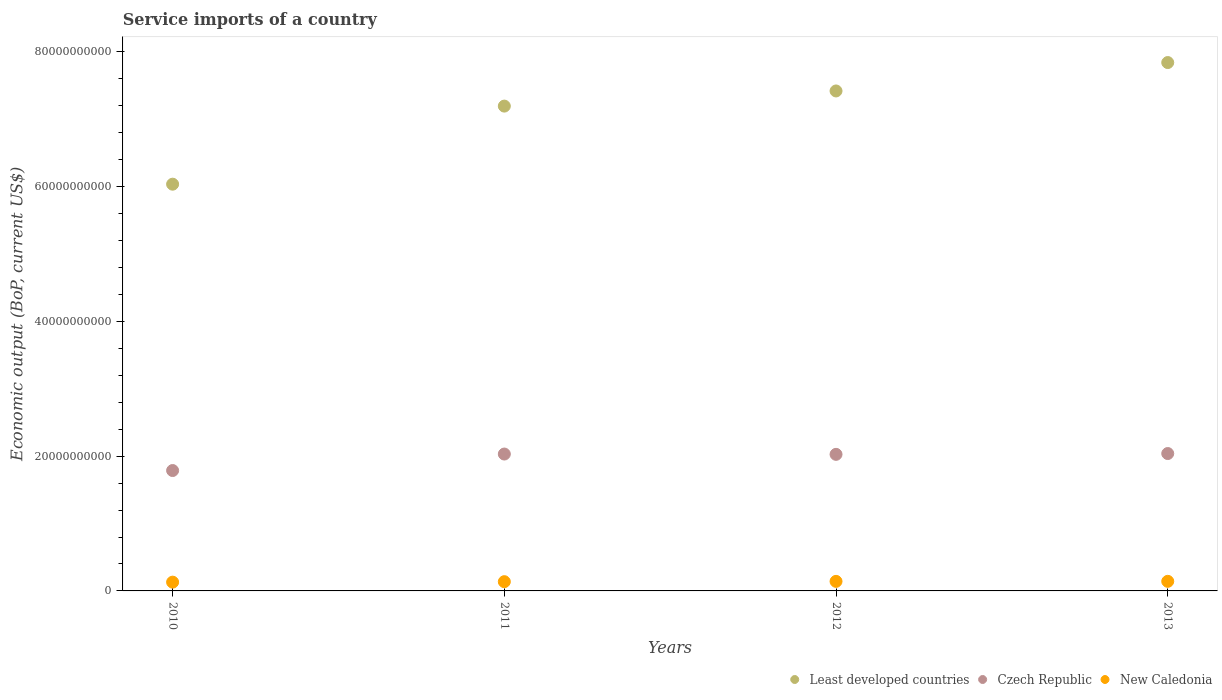Is the number of dotlines equal to the number of legend labels?
Offer a terse response. Yes. What is the service imports in Least developed countries in 2012?
Give a very brief answer. 7.42e+1. Across all years, what is the maximum service imports in Czech Republic?
Provide a short and direct response. 2.04e+1. Across all years, what is the minimum service imports in Least developed countries?
Your answer should be very brief. 6.04e+1. In which year was the service imports in New Caledonia maximum?
Make the answer very short. 2013. What is the total service imports in New Caledonia in the graph?
Provide a short and direct response. 5.51e+09. What is the difference between the service imports in Czech Republic in 2011 and that in 2012?
Make the answer very short. 4.52e+07. What is the difference between the service imports in Least developed countries in 2011 and the service imports in Czech Republic in 2012?
Your answer should be very brief. 5.17e+1. What is the average service imports in Least developed countries per year?
Give a very brief answer. 7.12e+1. In the year 2013, what is the difference between the service imports in New Caledonia and service imports in Least developed countries?
Give a very brief answer. -7.70e+1. In how many years, is the service imports in Least developed countries greater than 16000000000 US$?
Give a very brief answer. 4. What is the ratio of the service imports in Least developed countries in 2012 to that in 2013?
Your answer should be compact. 0.95. Is the difference between the service imports in New Caledonia in 2011 and 2012 greater than the difference between the service imports in Least developed countries in 2011 and 2012?
Make the answer very short. Yes. What is the difference between the highest and the second highest service imports in New Caledonia?
Offer a very short reply. 5.28e+06. What is the difference between the highest and the lowest service imports in Czech Republic?
Your answer should be compact. 2.52e+09. Does the service imports in Czech Republic monotonically increase over the years?
Give a very brief answer. No. Is the service imports in Least developed countries strictly greater than the service imports in New Caledonia over the years?
Keep it short and to the point. Yes. Is the service imports in Least developed countries strictly less than the service imports in Czech Republic over the years?
Give a very brief answer. No. How many dotlines are there?
Keep it short and to the point. 3. How many years are there in the graph?
Ensure brevity in your answer.  4. What is the difference between two consecutive major ticks on the Y-axis?
Make the answer very short. 2.00e+1. Does the graph contain grids?
Offer a very short reply. No. Where does the legend appear in the graph?
Make the answer very short. Bottom right. What is the title of the graph?
Make the answer very short. Service imports of a country. Does "Kuwait" appear as one of the legend labels in the graph?
Your answer should be compact. No. What is the label or title of the X-axis?
Provide a succinct answer. Years. What is the label or title of the Y-axis?
Provide a succinct answer. Economic output (BoP, current US$). What is the Economic output (BoP, current US$) in Least developed countries in 2010?
Provide a short and direct response. 6.04e+1. What is the Economic output (BoP, current US$) in Czech Republic in 2010?
Your answer should be very brief. 1.79e+1. What is the Economic output (BoP, current US$) in New Caledonia in 2010?
Make the answer very short. 1.30e+09. What is the Economic output (BoP, current US$) in Least developed countries in 2011?
Give a very brief answer. 7.19e+1. What is the Economic output (BoP, current US$) in Czech Republic in 2011?
Make the answer very short. 2.03e+1. What is the Economic output (BoP, current US$) of New Caledonia in 2011?
Your answer should be very brief. 1.37e+09. What is the Economic output (BoP, current US$) of Least developed countries in 2012?
Offer a very short reply. 7.42e+1. What is the Economic output (BoP, current US$) of Czech Republic in 2012?
Offer a very short reply. 2.03e+1. What is the Economic output (BoP, current US$) of New Caledonia in 2012?
Ensure brevity in your answer.  1.42e+09. What is the Economic output (BoP, current US$) in Least developed countries in 2013?
Offer a terse response. 7.84e+1. What is the Economic output (BoP, current US$) of Czech Republic in 2013?
Offer a very short reply. 2.04e+1. What is the Economic output (BoP, current US$) in New Caledonia in 2013?
Give a very brief answer. 1.42e+09. Across all years, what is the maximum Economic output (BoP, current US$) in Least developed countries?
Your answer should be compact. 7.84e+1. Across all years, what is the maximum Economic output (BoP, current US$) of Czech Republic?
Your answer should be very brief. 2.04e+1. Across all years, what is the maximum Economic output (BoP, current US$) of New Caledonia?
Make the answer very short. 1.42e+09. Across all years, what is the minimum Economic output (BoP, current US$) of Least developed countries?
Your response must be concise. 6.04e+1. Across all years, what is the minimum Economic output (BoP, current US$) in Czech Republic?
Ensure brevity in your answer.  1.79e+1. Across all years, what is the minimum Economic output (BoP, current US$) of New Caledonia?
Offer a very short reply. 1.30e+09. What is the total Economic output (BoP, current US$) of Least developed countries in the graph?
Provide a short and direct response. 2.85e+11. What is the total Economic output (BoP, current US$) of Czech Republic in the graph?
Keep it short and to the point. 7.88e+1. What is the total Economic output (BoP, current US$) in New Caledonia in the graph?
Provide a succinct answer. 5.51e+09. What is the difference between the Economic output (BoP, current US$) of Least developed countries in 2010 and that in 2011?
Keep it short and to the point. -1.16e+1. What is the difference between the Economic output (BoP, current US$) in Czech Republic in 2010 and that in 2011?
Offer a very short reply. -2.45e+09. What is the difference between the Economic output (BoP, current US$) of New Caledonia in 2010 and that in 2011?
Provide a short and direct response. -7.04e+07. What is the difference between the Economic output (BoP, current US$) in Least developed countries in 2010 and that in 2012?
Ensure brevity in your answer.  -1.38e+1. What is the difference between the Economic output (BoP, current US$) of Czech Republic in 2010 and that in 2012?
Provide a short and direct response. -2.40e+09. What is the difference between the Economic output (BoP, current US$) of New Caledonia in 2010 and that in 2012?
Your answer should be compact. -1.16e+08. What is the difference between the Economic output (BoP, current US$) in Least developed countries in 2010 and that in 2013?
Ensure brevity in your answer.  -1.80e+1. What is the difference between the Economic output (BoP, current US$) of Czech Republic in 2010 and that in 2013?
Offer a very short reply. -2.52e+09. What is the difference between the Economic output (BoP, current US$) in New Caledonia in 2010 and that in 2013?
Offer a very short reply. -1.21e+08. What is the difference between the Economic output (BoP, current US$) in Least developed countries in 2011 and that in 2012?
Provide a succinct answer. -2.25e+09. What is the difference between the Economic output (BoP, current US$) of Czech Republic in 2011 and that in 2012?
Offer a very short reply. 4.52e+07. What is the difference between the Economic output (BoP, current US$) of New Caledonia in 2011 and that in 2012?
Offer a terse response. -4.57e+07. What is the difference between the Economic output (BoP, current US$) in Least developed countries in 2011 and that in 2013?
Provide a short and direct response. -6.46e+09. What is the difference between the Economic output (BoP, current US$) in Czech Republic in 2011 and that in 2013?
Keep it short and to the point. -7.53e+07. What is the difference between the Economic output (BoP, current US$) in New Caledonia in 2011 and that in 2013?
Your answer should be compact. -5.10e+07. What is the difference between the Economic output (BoP, current US$) of Least developed countries in 2012 and that in 2013?
Your answer should be very brief. -4.21e+09. What is the difference between the Economic output (BoP, current US$) of Czech Republic in 2012 and that in 2013?
Provide a succinct answer. -1.21e+08. What is the difference between the Economic output (BoP, current US$) of New Caledonia in 2012 and that in 2013?
Provide a short and direct response. -5.28e+06. What is the difference between the Economic output (BoP, current US$) of Least developed countries in 2010 and the Economic output (BoP, current US$) of Czech Republic in 2011?
Give a very brief answer. 4.00e+1. What is the difference between the Economic output (BoP, current US$) in Least developed countries in 2010 and the Economic output (BoP, current US$) in New Caledonia in 2011?
Give a very brief answer. 5.90e+1. What is the difference between the Economic output (BoP, current US$) in Czech Republic in 2010 and the Economic output (BoP, current US$) in New Caledonia in 2011?
Provide a succinct answer. 1.65e+1. What is the difference between the Economic output (BoP, current US$) in Least developed countries in 2010 and the Economic output (BoP, current US$) in Czech Republic in 2012?
Ensure brevity in your answer.  4.01e+1. What is the difference between the Economic output (BoP, current US$) in Least developed countries in 2010 and the Economic output (BoP, current US$) in New Caledonia in 2012?
Your answer should be compact. 5.89e+1. What is the difference between the Economic output (BoP, current US$) of Czech Republic in 2010 and the Economic output (BoP, current US$) of New Caledonia in 2012?
Keep it short and to the point. 1.64e+1. What is the difference between the Economic output (BoP, current US$) of Least developed countries in 2010 and the Economic output (BoP, current US$) of Czech Republic in 2013?
Your answer should be very brief. 4.00e+1. What is the difference between the Economic output (BoP, current US$) of Least developed countries in 2010 and the Economic output (BoP, current US$) of New Caledonia in 2013?
Ensure brevity in your answer.  5.89e+1. What is the difference between the Economic output (BoP, current US$) of Czech Republic in 2010 and the Economic output (BoP, current US$) of New Caledonia in 2013?
Provide a short and direct response. 1.64e+1. What is the difference between the Economic output (BoP, current US$) of Least developed countries in 2011 and the Economic output (BoP, current US$) of Czech Republic in 2012?
Your response must be concise. 5.17e+1. What is the difference between the Economic output (BoP, current US$) of Least developed countries in 2011 and the Economic output (BoP, current US$) of New Caledonia in 2012?
Your answer should be compact. 7.05e+1. What is the difference between the Economic output (BoP, current US$) in Czech Republic in 2011 and the Economic output (BoP, current US$) in New Caledonia in 2012?
Your response must be concise. 1.89e+1. What is the difference between the Economic output (BoP, current US$) of Least developed countries in 2011 and the Economic output (BoP, current US$) of Czech Republic in 2013?
Offer a very short reply. 5.16e+1. What is the difference between the Economic output (BoP, current US$) in Least developed countries in 2011 and the Economic output (BoP, current US$) in New Caledonia in 2013?
Provide a short and direct response. 7.05e+1. What is the difference between the Economic output (BoP, current US$) in Czech Republic in 2011 and the Economic output (BoP, current US$) in New Caledonia in 2013?
Ensure brevity in your answer.  1.89e+1. What is the difference between the Economic output (BoP, current US$) of Least developed countries in 2012 and the Economic output (BoP, current US$) of Czech Republic in 2013?
Provide a succinct answer. 5.38e+1. What is the difference between the Economic output (BoP, current US$) in Least developed countries in 2012 and the Economic output (BoP, current US$) in New Caledonia in 2013?
Your response must be concise. 7.28e+1. What is the difference between the Economic output (BoP, current US$) in Czech Republic in 2012 and the Economic output (BoP, current US$) in New Caledonia in 2013?
Your answer should be very brief. 1.88e+1. What is the average Economic output (BoP, current US$) of Least developed countries per year?
Offer a terse response. 7.12e+1. What is the average Economic output (BoP, current US$) of Czech Republic per year?
Provide a short and direct response. 1.97e+1. What is the average Economic output (BoP, current US$) in New Caledonia per year?
Provide a short and direct response. 1.38e+09. In the year 2010, what is the difference between the Economic output (BoP, current US$) in Least developed countries and Economic output (BoP, current US$) in Czech Republic?
Your answer should be compact. 4.25e+1. In the year 2010, what is the difference between the Economic output (BoP, current US$) of Least developed countries and Economic output (BoP, current US$) of New Caledonia?
Your response must be concise. 5.91e+1. In the year 2010, what is the difference between the Economic output (BoP, current US$) of Czech Republic and Economic output (BoP, current US$) of New Caledonia?
Offer a very short reply. 1.66e+1. In the year 2011, what is the difference between the Economic output (BoP, current US$) of Least developed countries and Economic output (BoP, current US$) of Czech Republic?
Your answer should be very brief. 5.16e+1. In the year 2011, what is the difference between the Economic output (BoP, current US$) in Least developed countries and Economic output (BoP, current US$) in New Caledonia?
Provide a succinct answer. 7.06e+1. In the year 2011, what is the difference between the Economic output (BoP, current US$) in Czech Republic and Economic output (BoP, current US$) in New Caledonia?
Offer a very short reply. 1.89e+1. In the year 2012, what is the difference between the Economic output (BoP, current US$) of Least developed countries and Economic output (BoP, current US$) of Czech Republic?
Keep it short and to the point. 5.39e+1. In the year 2012, what is the difference between the Economic output (BoP, current US$) of Least developed countries and Economic output (BoP, current US$) of New Caledonia?
Make the answer very short. 7.28e+1. In the year 2012, what is the difference between the Economic output (BoP, current US$) in Czech Republic and Economic output (BoP, current US$) in New Caledonia?
Keep it short and to the point. 1.88e+1. In the year 2013, what is the difference between the Economic output (BoP, current US$) in Least developed countries and Economic output (BoP, current US$) in Czech Republic?
Offer a very short reply. 5.80e+1. In the year 2013, what is the difference between the Economic output (BoP, current US$) in Least developed countries and Economic output (BoP, current US$) in New Caledonia?
Offer a terse response. 7.70e+1. In the year 2013, what is the difference between the Economic output (BoP, current US$) of Czech Republic and Economic output (BoP, current US$) of New Caledonia?
Keep it short and to the point. 1.90e+1. What is the ratio of the Economic output (BoP, current US$) of Least developed countries in 2010 to that in 2011?
Provide a short and direct response. 0.84. What is the ratio of the Economic output (BoP, current US$) of Czech Republic in 2010 to that in 2011?
Keep it short and to the point. 0.88. What is the ratio of the Economic output (BoP, current US$) in New Caledonia in 2010 to that in 2011?
Your answer should be compact. 0.95. What is the ratio of the Economic output (BoP, current US$) of Least developed countries in 2010 to that in 2012?
Offer a terse response. 0.81. What is the ratio of the Economic output (BoP, current US$) in Czech Republic in 2010 to that in 2012?
Your answer should be very brief. 0.88. What is the ratio of the Economic output (BoP, current US$) in New Caledonia in 2010 to that in 2012?
Your response must be concise. 0.92. What is the ratio of the Economic output (BoP, current US$) in Least developed countries in 2010 to that in 2013?
Keep it short and to the point. 0.77. What is the ratio of the Economic output (BoP, current US$) of Czech Republic in 2010 to that in 2013?
Keep it short and to the point. 0.88. What is the ratio of the Economic output (BoP, current US$) in New Caledonia in 2010 to that in 2013?
Offer a terse response. 0.91. What is the ratio of the Economic output (BoP, current US$) of Least developed countries in 2011 to that in 2012?
Give a very brief answer. 0.97. What is the ratio of the Economic output (BoP, current US$) of New Caledonia in 2011 to that in 2012?
Offer a very short reply. 0.97. What is the ratio of the Economic output (BoP, current US$) in Least developed countries in 2011 to that in 2013?
Provide a succinct answer. 0.92. What is the ratio of the Economic output (BoP, current US$) in New Caledonia in 2011 to that in 2013?
Provide a succinct answer. 0.96. What is the ratio of the Economic output (BoP, current US$) in Least developed countries in 2012 to that in 2013?
Provide a short and direct response. 0.95. What is the difference between the highest and the second highest Economic output (BoP, current US$) of Least developed countries?
Your response must be concise. 4.21e+09. What is the difference between the highest and the second highest Economic output (BoP, current US$) of Czech Republic?
Ensure brevity in your answer.  7.53e+07. What is the difference between the highest and the second highest Economic output (BoP, current US$) in New Caledonia?
Provide a succinct answer. 5.28e+06. What is the difference between the highest and the lowest Economic output (BoP, current US$) of Least developed countries?
Keep it short and to the point. 1.80e+1. What is the difference between the highest and the lowest Economic output (BoP, current US$) in Czech Republic?
Keep it short and to the point. 2.52e+09. What is the difference between the highest and the lowest Economic output (BoP, current US$) of New Caledonia?
Your response must be concise. 1.21e+08. 